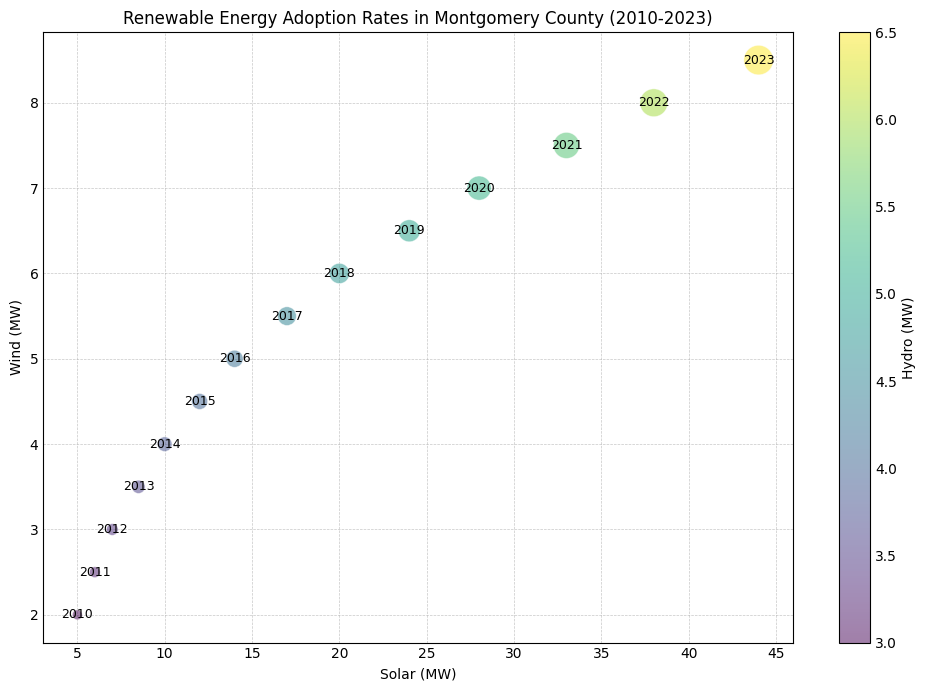Which year had the highest adoption rate? By looking at the plot, we can identify the year with the largest bubbles indicating higher adoption rates. The largest bubble appears for 2023.
Answer: 2023 Did Solar or Wind have greater capacity in 2015? By finding the corresponding year on the plot and reading the positions, we see that Solar had greater capacity (around 12 MW) compared to Wind (around 4.5 MW).
Answer: Solar What is the color indication on the chart? By observing the color gradient and the color bar on the side, we can determine that the color indicates the capacity of Hydro power in MW.
Answer: Hydro capacity Which year saw the largest increase in Solar capacity from the previous year? By comparing the Solar capacity year over year, we see the largest increase was between 2022 (38 MW) and 2023 (44 MW), a difference of 6 MW.
Answer: 2023 What was the total Solar capacity in 2013 and 2014 combined? Summing the solar capacities for 2013 (8.5 MW) and 2014 (10 MW), we get 8.5 + 10 = 18.5 MW.
Answer: 18.5 MW Which year had the smallest adoption rate? By identifying the smallest bubble on the plot, we find that the year with the smallest adoption rate is 2010.
Answer: 2010 How does the growth trend of Wind power compare with Solar power from 2010 to 2023? By following the trend of the bubbles' horizontal (Solar) and vertical (Wind) positions, we can determine that both Solar and Wind power capacities have increased over time, but Solar power has grown more significantly.
Answer: Solar grew more If you compare the hydro capacity in 2015 and 2020, which year had a greater value and by how much? By reading from the color bar and the chart, 2015 had around 4 MW and 2020 had around 5.2 MW. The increase is 5.2 - 4 = 1.2 MW.
Answer: 2020 by 1.2 MW Was the adoption rate higher in 2018 or 2020? By comparing the size of the bubbles, we see that the bubble for 2020 is larger than that for 2018, indicating a higher adoption rate in 2020.
Answer: 2020 What's the combined capacity of Wind and Hydro in 2017? Adding Wind (5.5 MW) and Hydro (4.5 MW) capacities for 2017, we get 5.5 + 4.5 = 10 MW.
Answer: 10 MW 